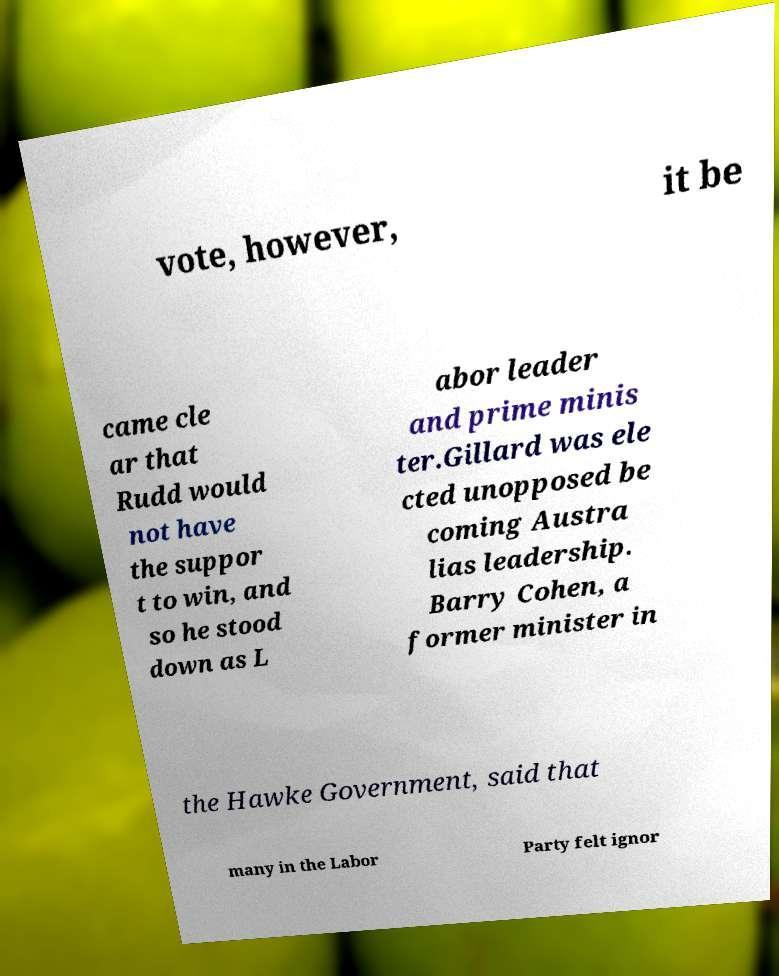What messages or text are displayed in this image? I need them in a readable, typed format. vote, however, it be came cle ar that Rudd would not have the suppor t to win, and so he stood down as L abor leader and prime minis ter.Gillard was ele cted unopposed be coming Austra lias leadership. Barry Cohen, a former minister in the Hawke Government, said that many in the Labor Party felt ignor 